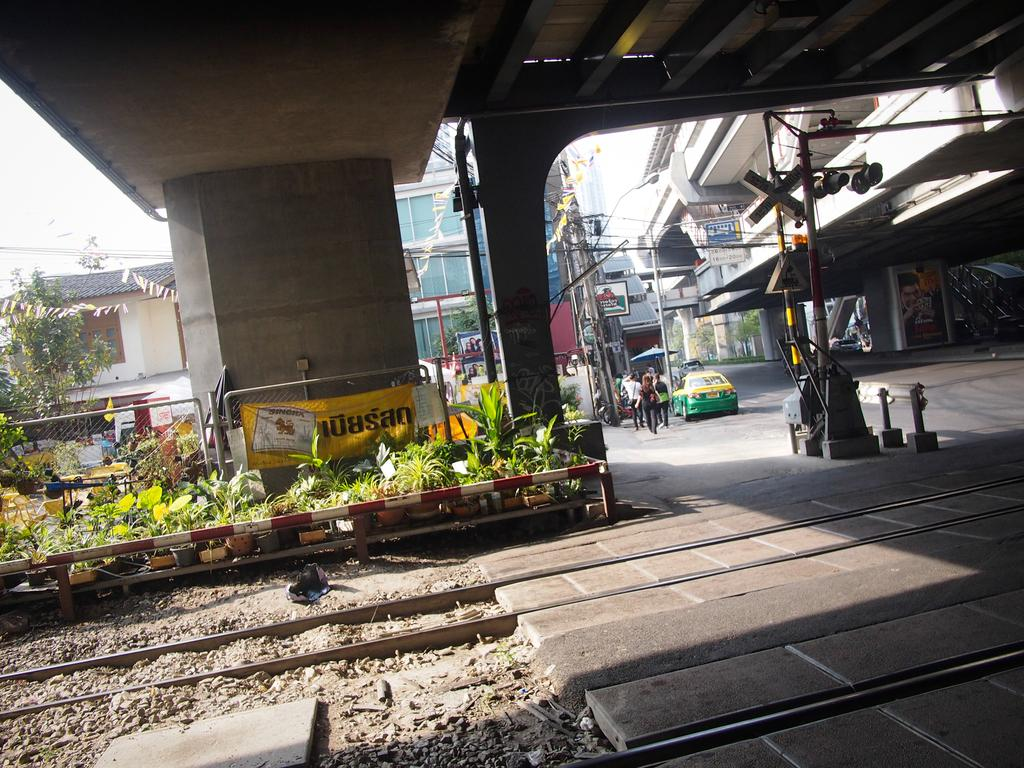What can be seen on the ground in the image? There are tracks in the image. What type of vegetation is present in the image? There are plants and trees in the image. What type of barrier can be seen in the image? There is a fence in the image. What structures can be seen in the background of the image? There are poles, buildings, and hoardings in the background of the image. What else can be seen in the background of the image? There are vehicles and a group of people in the background of the image. How many hats are visible on the people in the image? There is no mention of hats in the image, so it is impossible to determine how many are visible. What type of houses can be seen in the image? There is no mention of houses in the image; the background features buildings and hoardings, but not houses. 